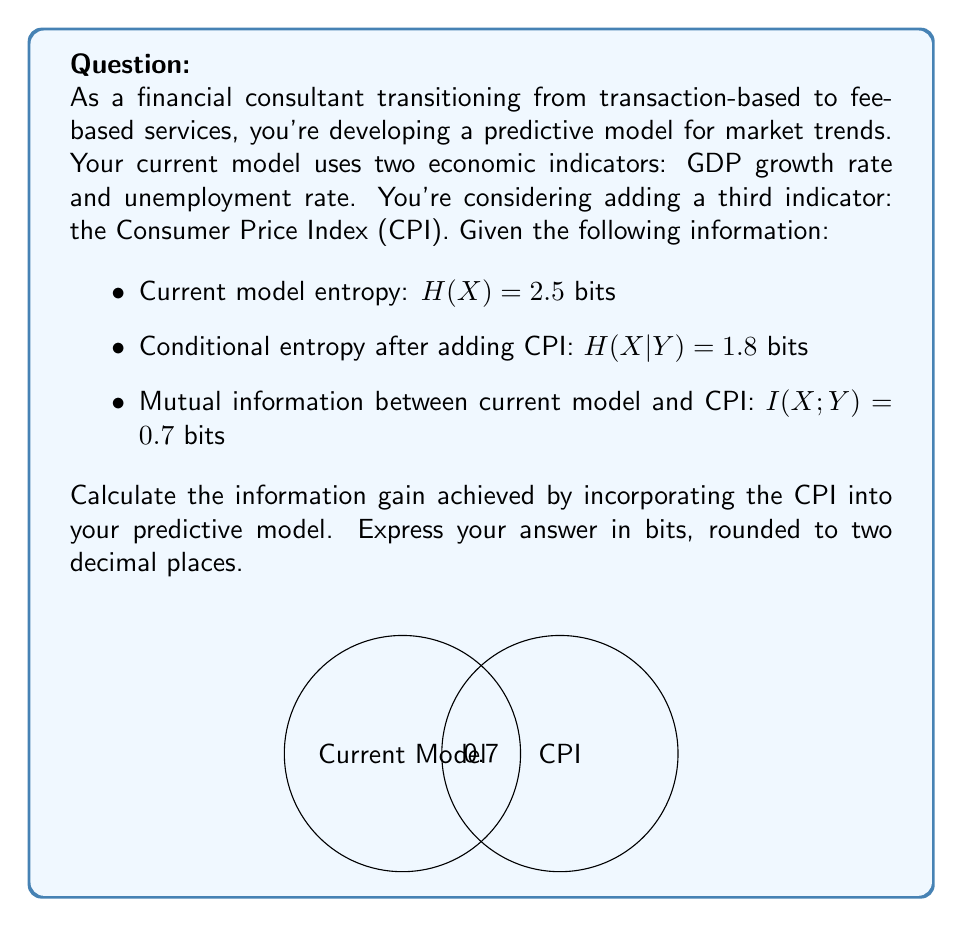Provide a solution to this math problem. To solve this problem, we'll use the concept of information gain in information theory. The information gain is equivalent to the mutual information between the current model (X) and the new indicator (Y, which is CPI in this case).

Step 1: Recall the formula for mutual information:
$$I(X;Y) = H(X) - H(X|Y)$$

Where:
- $I(X;Y)$ is the mutual information between X and Y
- $H(X)$ is the entropy of the current model
- $H(X|Y)$ is the conditional entropy of X given Y

Step 2: We're given the values:
- $H(X) = 2.5$ bits
- $H(X|Y) = 1.8$ bits
- $I(X;Y) = 0.7$ bits

Step 3: We can verify the mutual information using the given values:
$$I(X;Y) = H(X) - H(X|Y) = 2.5 - 1.8 = 0.7\text{ bits}$$

This matches the given mutual information, confirming our calculation.

Step 4: The information gain is equal to the mutual information. Therefore, the information gain from incorporating the CPI into the predictive model is 0.7 bits.
Answer: 0.70 bits 